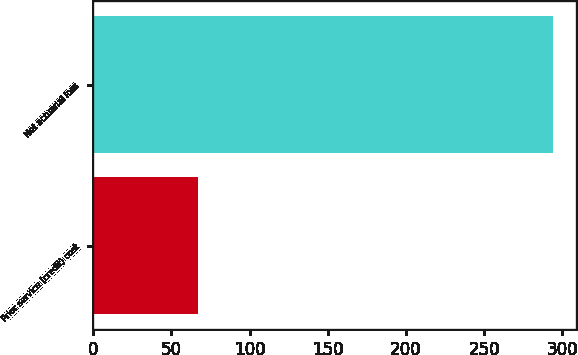Convert chart. <chart><loc_0><loc_0><loc_500><loc_500><bar_chart><fcel>Prior service (credit) cost<fcel>Net actuarial loss<nl><fcel>67<fcel>294<nl></chart> 